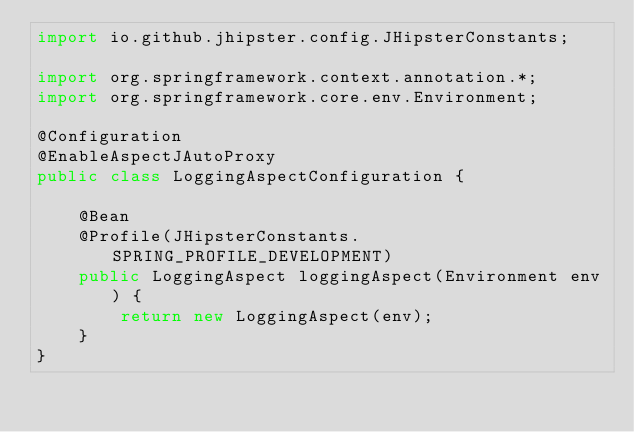Convert code to text. <code><loc_0><loc_0><loc_500><loc_500><_Java_>import io.github.jhipster.config.JHipsterConstants;

import org.springframework.context.annotation.*;
import org.springframework.core.env.Environment;

@Configuration
@EnableAspectJAutoProxy
public class LoggingAspectConfiguration {

    @Bean
    @Profile(JHipsterConstants.SPRING_PROFILE_DEVELOPMENT)
    public LoggingAspect loggingAspect(Environment env) {
        return new LoggingAspect(env);
    }
}
</code> 